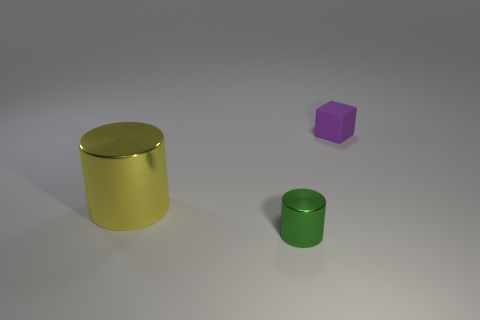Is the number of large things that are to the right of the tiny metal thing greater than the number of blocks that are in front of the purple thing?
Ensure brevity in your answer.  No. There is a small thing to the left of the object that is right of the tiny green object; what color is it?
Give a very brief answer. Green. What number of balls are either small yellow rubber objects or big yellow shiny objects?
Your answer should be compact. 0. What number of objects are right of the big yellow thing and on the left side of the tiny purple cube?
Provide a short and direct response. 1. What color is the metal cylinder that is to the right of the big metal cylinder?
Your response must be concise. Green. What is the size of the thing that is made of the same material as the green cylinder?
Keep it short and to the point. Large. There is a metal cylinder on the right side of the yellow thing; how many cylinders are behind it?
Ensure brevity in your answer.  1. How many objects are on the right side of the yellow shiny cylinder?
Keep it short and to the point. 2. The tiny thing that is to the right of the metal cylinder that is in front of the metallic cylinder that is behind the small green shiny cylinder is what color?
Ensure brevity in your answer.  Purple. There is a metal cylinder that is on the left side of the small green metallic thing; is its color the same as the cylinder right of the large yellow metal thing?
Offer a very short reply. No. 